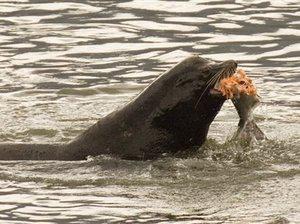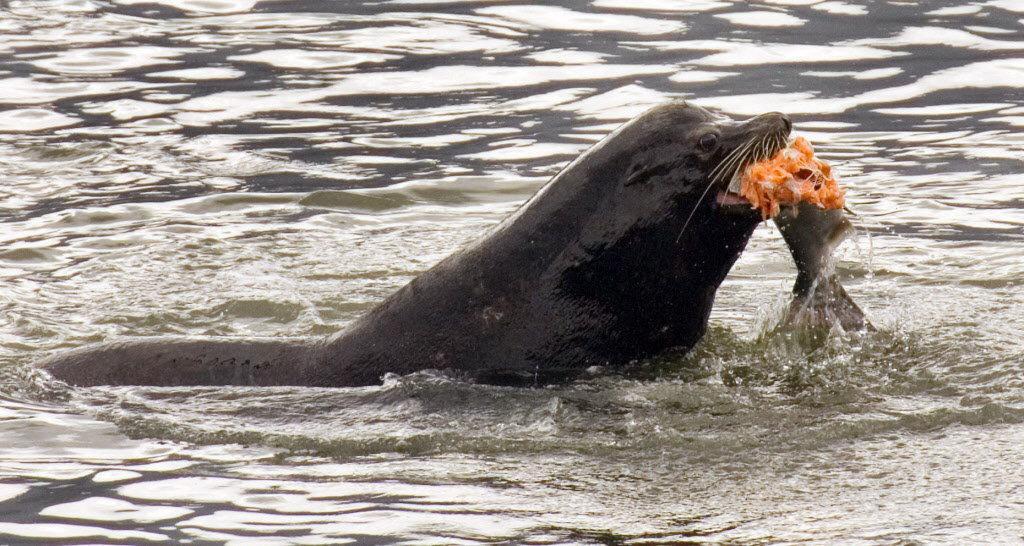The first image is the image on the left, the second image is the image on the right. Examine the images to the left and right. Is the description "Each image shows one dark seal with its head showing above water, and in at least one image, the seal is chewing on torn orange-fleshed fish." accurate? Answer yes or no. Yes. 